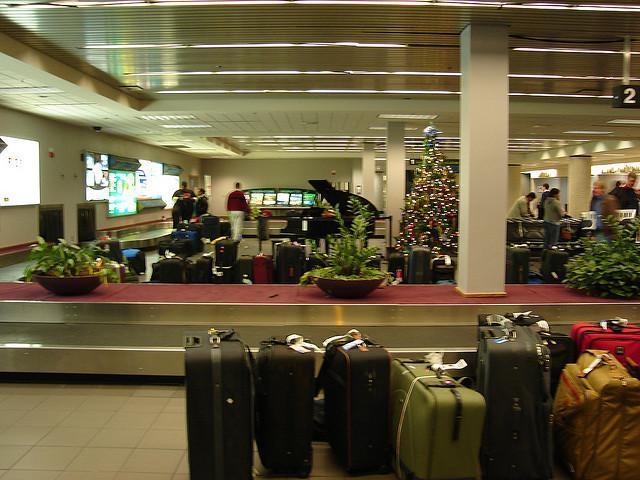How many potted plants are visible?
Give a very brief answer. 3. How many suitcases are there?
Give a very brief answer. 7. How many trains are shown?
Give a very brief answer. 0. 